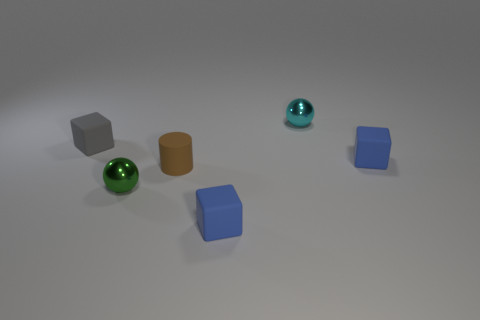There is a tiny green thing; how many blue rubber things are behind it?
Offer a terse response. 1. Are there any brown objects that have the same size as the gray rubber thing?
Keep it short and to the point. Yes. There is a small metal object in front of the brown cylinder; does it have the same shape as the small cyan thing?
Keep it short and to the point. Yes. The matte cylinder is what color?
Your response must be concise. Brown. Are any cyan metallic balls visible?
Your answer should be very brief. Yes. There is a metallic object that is in front of the tiny metallic ball on the right side of the thing in front of the green sphere; what shape is it?
Give a very brief answer. Sphere. Is the number of small shiny spheres in front of the small green object the same as the number of gray cubes?
Offer a very short reply. No. Does the tiny cyan metallic object have the same shape as the green object?
Keep it short and to the point. Yes. What number of objects are tiny green spheres that are on the right side of the tiny gray rubber cube or rubber cubes?
Ensure brevity in your answer.  4. Are there the same number of blue objects behind the cylinder and shiny objects on the right side of the tiny green shiny thing?
Your response must be concise. Yes. 